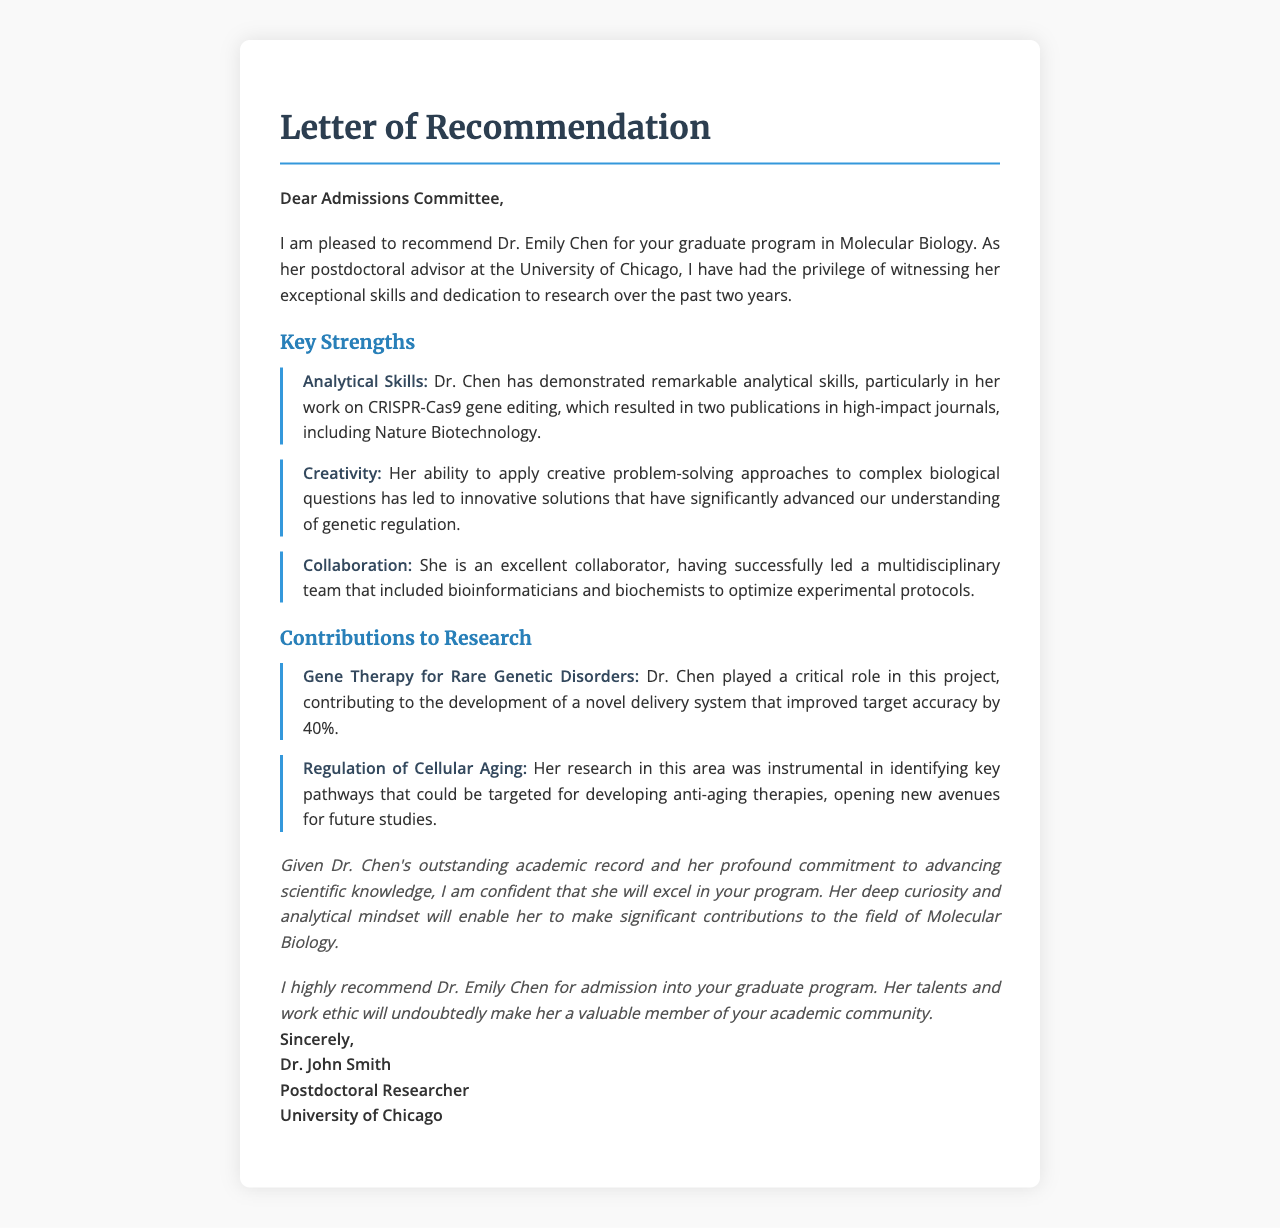What is the name of the student recommended? The document specifically states the name of the student being recommended is Dr. Emily Chen.
Answer: Dr. Emily Chen Who is the author of the recommendation letter? The letter is signed by Dr. John Smith, who is the author of the recommendation.
Answer: Dr. John Smith What department is Dr. Chen applying to? The recommendation clearly mentions that Dr. Chen is applying to the graduate program in Molecular Biology.
Answer: Molecular Biology How many years has Dr. Chen worked with her advisor? The letter states that the author has observed Dr. Chen's work over the past two years.
Answer: two years What is one specific publication mentioned in the letter? The letter highlights Dr. Chen's publications, particularly noting the journal Nature Biotechnology.
Answer: Nature Biotechnology What key strength of Dr. Chen relates to team dynamics? The letter describes Dr. Chen's ability to collaborate effectively within a multidisciplinary team as an important strength.
Answer: Collaboration What project improved target accuracy by 40%? The project involving Gene Therapy for Rare Genetic Disorders is mentioned as having a 40% improvement in target accuracy.
Answer: Gene Therapy for Rare Genetic Disorders What is a primary focus of Dr. Chen’s research mentioned in the letter? Dr. Chen's research on the regulation of cellular aging is highlighted as a significant area of focus.
Answer: Regulation of Cellular Aging What conclusion does the author reach regarding Dr. Chen's potential? The author is confident in Dr. Chen's ability to excel in the graduate program.
Answer: excel 